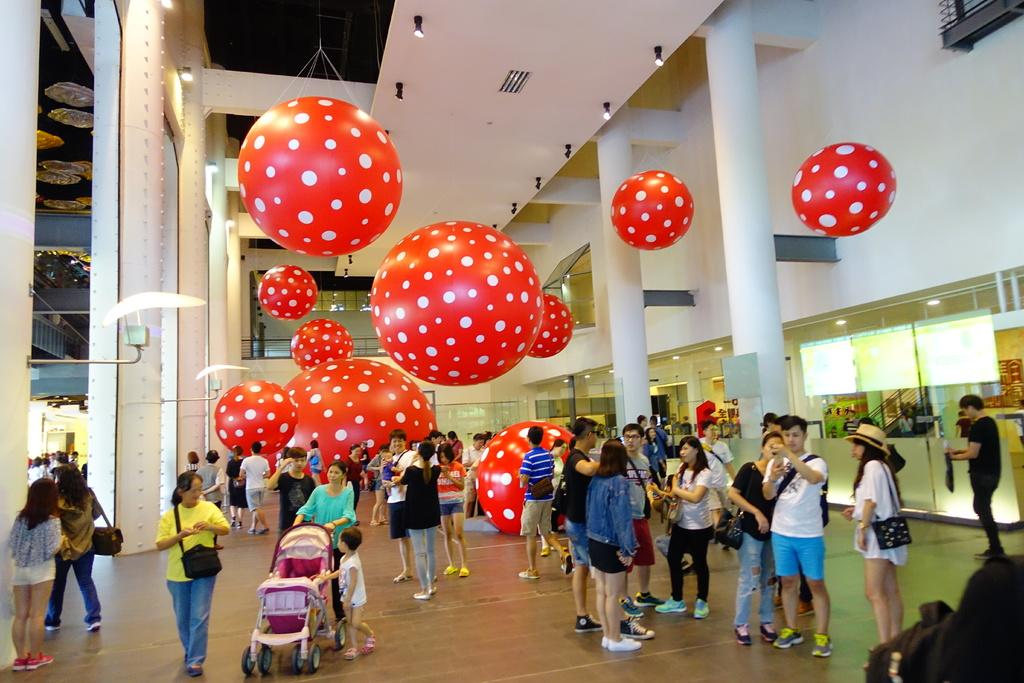Who or what is present in the image? There are people in the image. What architectural feature can be seen in the image? There are stairs in the image. What type of electronic devices are visible in the image? There are screens in the image. What decorative items can be seen in the image? There are balloons in the image. What type of lighting is present in the image? There are lights in the image. What color is the wall in the image? There is a white color wall in the image. What type of mobility aid is at the front of the image? There is a baby wheelchair at the front of the image. What type of building is being constructed in the image? There is no mention of a building being constructed in the image. What type of wax sculpture can be seen in the image? There is no wax sculpture present in the image. 